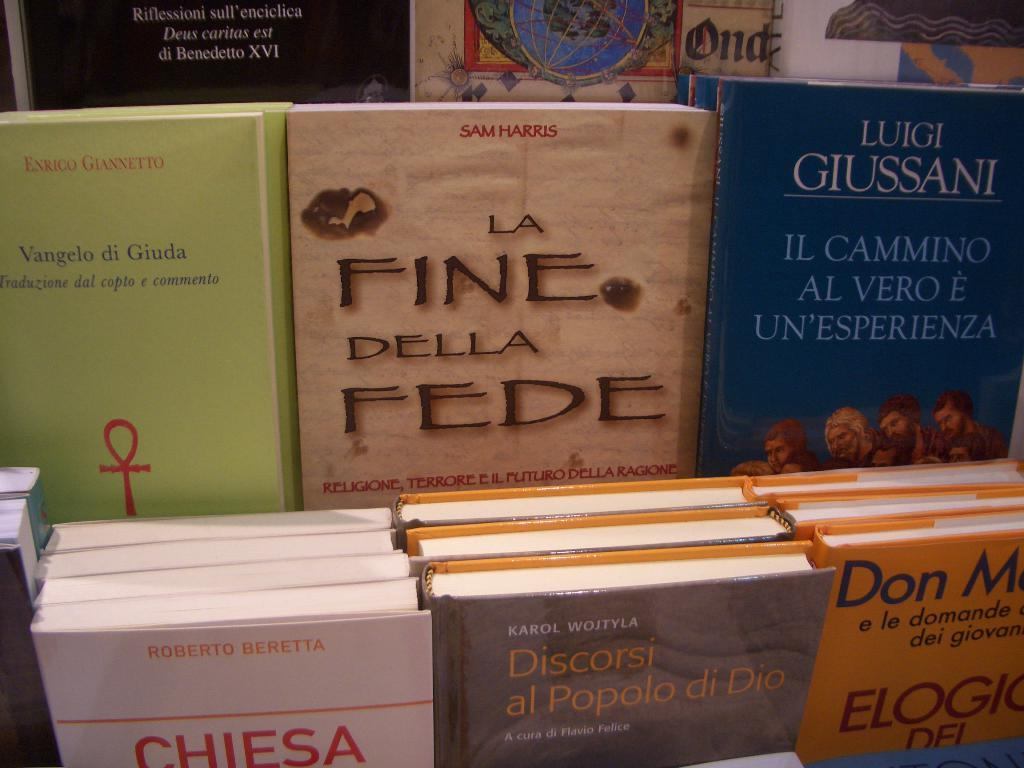What objects are arranged in rows in the image? There are books placed in rows in the image. How are the books organized in the image? The books are arranged in rows, which suggests they might be part of a collection or library. What might be the purpose of organizing the books in this manner? Organizing the books in rows could make it easier to locate specific titles or to create a visually appealing display. What type of throat condition can be seen in the image? There is no throat condition present in the image; it features books arranged in rows. Can you describe the monkey's behavior in the image? There is no monkey present in the image; it features books arranged in rows. 